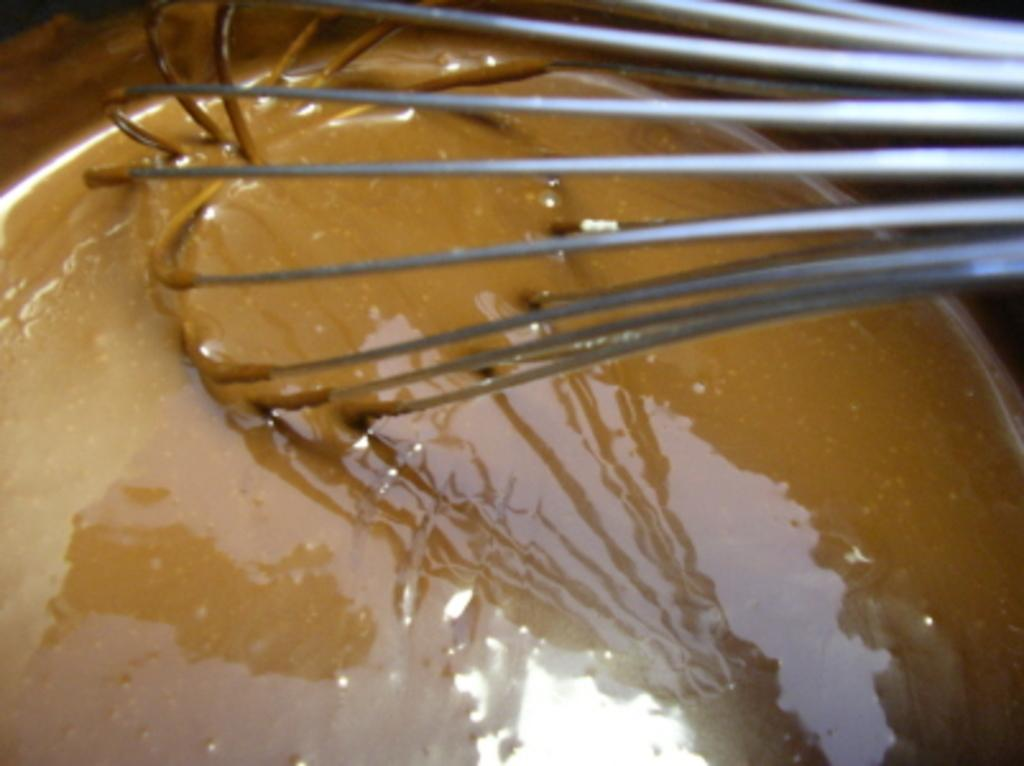What can be seen in the image that resembles hair-like structures? There are whiskers visible in the image. What is contained in the bowl that is visible in the image? There is a bowl with liquid in it. How many shoes are placed on the tray in the image? There is no tray or shoes present in the image. What type of uniform is the fireman wearing in the image? There is no fireman present in the image. 